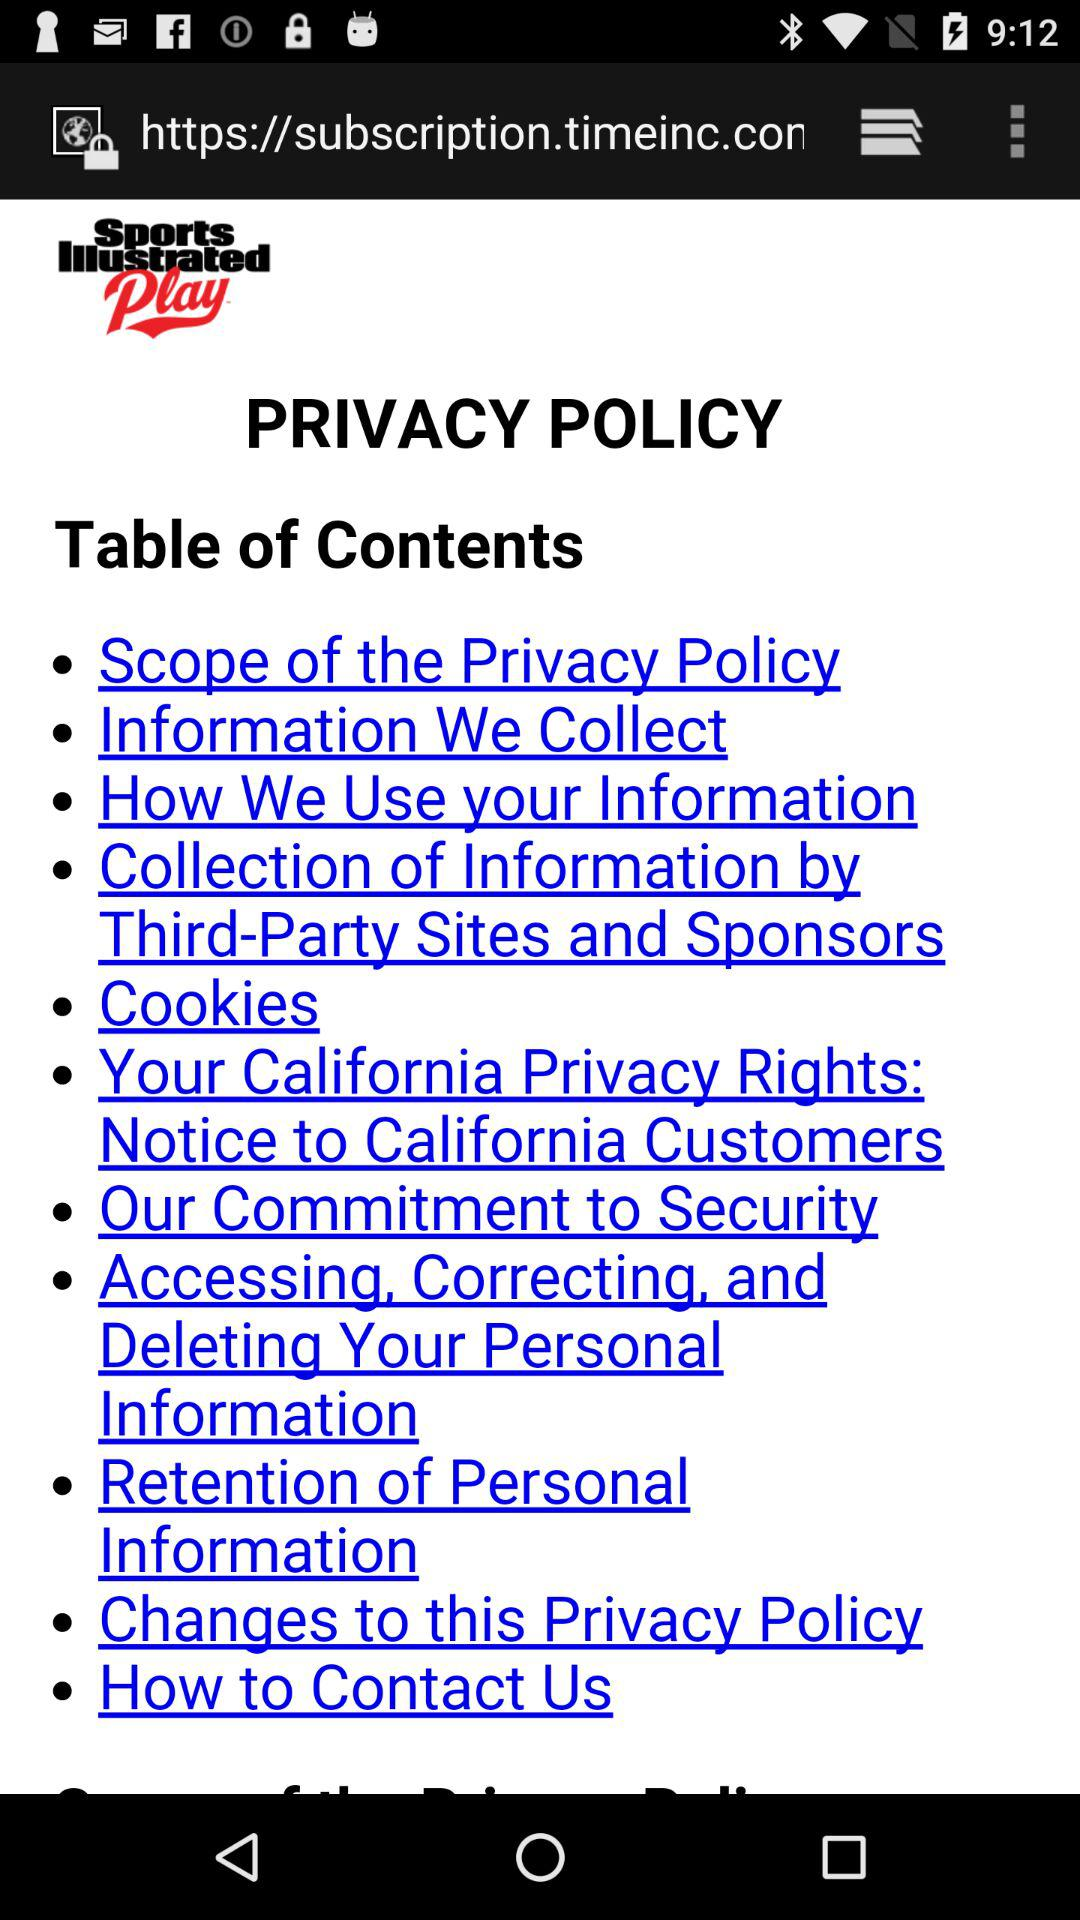What page is "Scope of the Privacy Policy" on?
When the provided information is insufficient, respond with <no answer>. <no answer> 